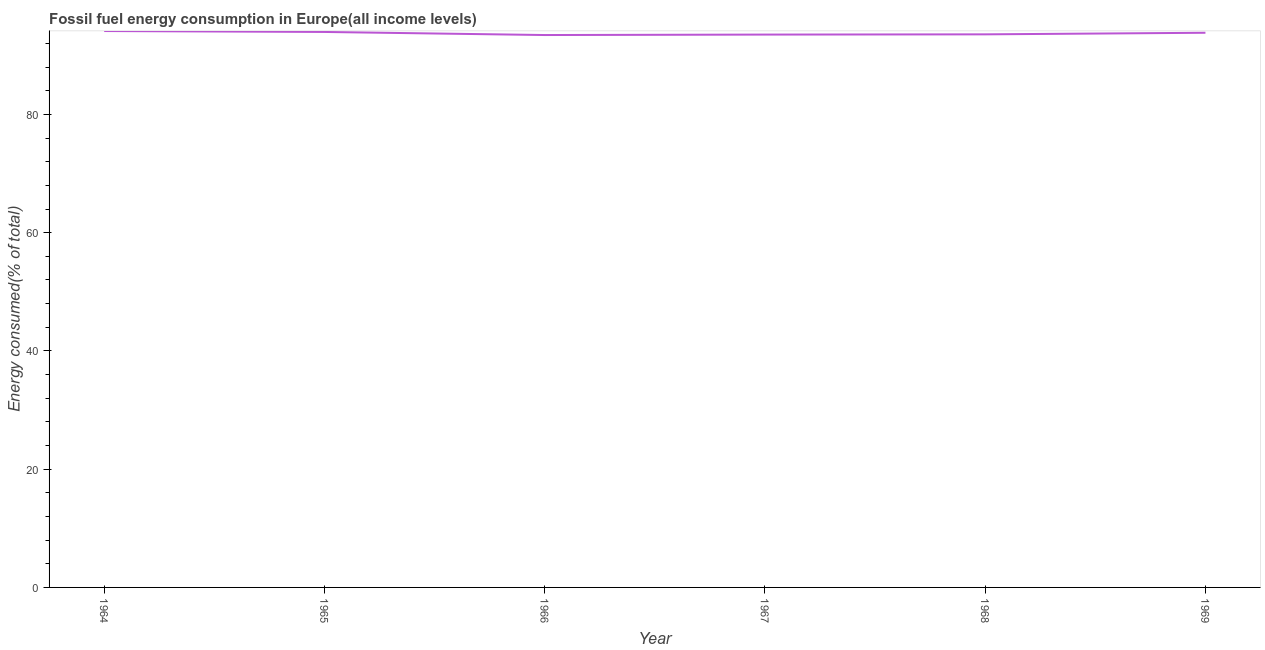What is the fossil fuel energy consumption in 1964?
Offer a very short reply. 94.11. Across all years, what is the maximum fossil fuel energy consumption?
Your answer should be compact. 94.11. Across all years, what is the minimum fossil fuel energy consumption?
Your answer should be very brief. 93.43. In which year was the fossil fuel energy consumption maximum?
Your answer should be compact. 1964. In which year was the fossil fuel energy consumption minimum?
Provide a succinct answer. 1966. What is the sum of the fossil fuel energy consumption?
Ensure brevity in your answer.  562.38. What is the difference between the fossil fuel energy consumption in 1964 and 1968?
Provide a succinct answer. 0.56. What is the average fossil fuel energy consumption per year?
Offer a terse response. 93.73. What is the median fossil fuel energy consumption?
Provide a succinct answer. 93.68. In how many years, is the fossil fuel energy consumption greater than 72 %?
Keep it short and to the point. 6. Do a majority of the years between 1967 and 1966 (inclusive) have fossil fuel energy consumption greater than 64 %?
Offer a terse response. No. What is the ratio of the fossil fuel energy consumption in 1964 to that in 1969?
Offer a very short reply. 1. Is the fossil fuel energy consumption in 1964 less than that in 1966?
Your answer should be compact. No. Is the difference between the fossil fuel energy consumption in 1965 and 1967 greater than the difference between any two years?
Keep it short and to the point. No. What is the difference between the highest and the second highest fossil fuel energy consumption?
Your response must be concise. 0.16. Is the sum of the fossil fuel energy consumption in 1964 and 1966 greater than the maximum fossil fuel energy consumption across all years?
Provide a short and direct response. Yes. What is the difference between the highest and the lowest fossil fuel energy consumption?
Your response must be concise. 0.68. In how many years, is the fossil fuel energy consumption greater than the average fossil fuel energy consumption taken over all years?
Offer a terse response. 3. Does the fossil fuel energy consumption monotonically increase over the years?
Offer a terse response. No. How many lines are there?
Offer a very short reply. 1. How many years are there in the graph?
Make the answer very short. 6. Does the graph contain grids?
Provide a succinct answer. No. What is the title of the graph?
Offer a terse response. Fossil fuel energy consumption in Europe(all income levels). What is the label or title of the Y-axis?
Your answer should be compact. Energy consumed(% of total). What is the Energy consumed(% of total) of 1964?
Provide a short and direct response. 94.11. What is the Energy consumed(% of total) of 1965?
Your answer should be very brief. 93.95. What is the Energy consumed(% of total) of 1966?
Keep it short and to the point. 93.43. What is the Energy consumed(% of total) in 1967?
Keep it short and to the point. 93.51. What is the Energy consumed(% of total) of 1968?
Keep it short and to the point. 93.55. What is the Energy consumed(% of total) of 1969?
Make the answer very short. 93.82. What is the difference between the Energy consumed(% of total) in 1964 and 1965?
Make the answer very short. 0.16. What is the difference between the Energy consumed(% of total) in 1964 and 1966?
Your answer should be very brief. 0.68. What is the difference between the Energy consumed(% of total) in 1964 and 1967?
Your answer should be compact. 0.6. What is the difference between the Energy consumed(% of total) in 1964 and 1968?
Your answer should be very brief. 0.56. What is the difference between the Energy consumed(% of total) in 1964 and 1969?
Make the answer very short. 0.29. What is the difference between the Energy consumed(% of total) in 1965 and 1966?
Provide a short and direct response. 0.52. What is the difference between the Energy consumed(% of total) in 1965 and 1967?
Your answer should be compact. 0.45. What is the difference between the Energy consumed(% of total) in 1965 and 1968?
Make the answer very short. 0.41. What is the difference between the Energy consumed(% of total) in 1965 and 1969?
Your response must be concise. 0.14. What is the difference between the Energy consumed(% of total) in 1966 and 1967?
Your response must be concise. -0.08. What is the difference between the Energy consumed(% of total) in 1966 and 1968?
Your response must be concise. -0.11. What is the difference between the Energy consumed(% of total) in 1966 and 1969?
Your answer should be compact. -0.38. What is the difference between the Energy consumed(% of total) in 1967 and 1968?
Provide a succinct answer. -0.04. What is the difference between the Energy consumed(% of total) in 1967 and 1969?
Give a very brief answer. -0.31. What is the difference between the Energy consumed(% of total) in 1968 and 1969?
Provide a succinct answer. -0.27. What is the ratio of the Energy consumed(% of total) in 1964 to that in 1966?
Give a very brief answer. 1.01. What is the ratio of the Energy consumed(% of total) in 1964 to that in 1967?
Provide a short and direct response. 1.01. What is the ratio of the Energy consumed(% of total) in 1964 to that in 1968?
Offer a very short reply. 1.01. What is the ratio of the Energy consumed(% of total) in 1964 to that in 1969?
Your answer should be very brief. 1. What is the ratio of the Energy consumed(% of total) in 1965 to that in 1966?
Your answer should be compact. 1.01. What is the ratio of the Energy consumed(% of total) in 1966 to that in 1969?
Offer a terse response. 1. What is the ratio of the Energy consumed(% of total) in 1967 to that in 1968?
Provide a succinct answer. 1. What is the ratio of the Energy consumed(% of total) in 1967 to that in 1969?
Offer a terse response. 1. What is the ratio of the Energy consumed(% of total) in 1968 to that in 1969?
Your answer should be compact. 1. 